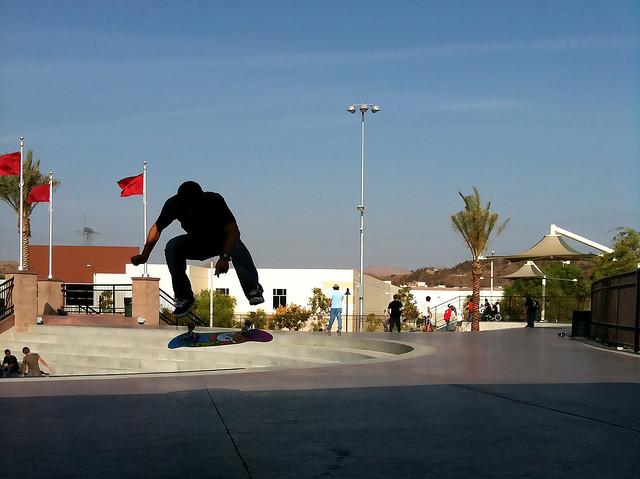How many flags are visible?
Answer briefly. 3. Is this a skateboard competition?
Write a very short answer. No. Where are the men at?
Keep it brief. Skatepark. How is the weather?
Answer briefly. Sunny. Is this man on a beach?
Short answer required. No. What sport is he playing?
Quick response, please. Skateboarding. Did the skateboarder fall?
Be succinct. No. What is the main feature of the skate park made from?
Be succinct. Cement. Is the man wearing safety gear?
Answer briefly. No. Where is the boy skateboarding?
Answer briefly. Skate park. What sport are they playing?
Be succinct. Skateboarding. What is the person using to do tricks?
Short answer required. Skateboard. What is the person jumping over?
Concise answer only. Nothing. How many flags are in the picture?
Answer briefly. 3. 